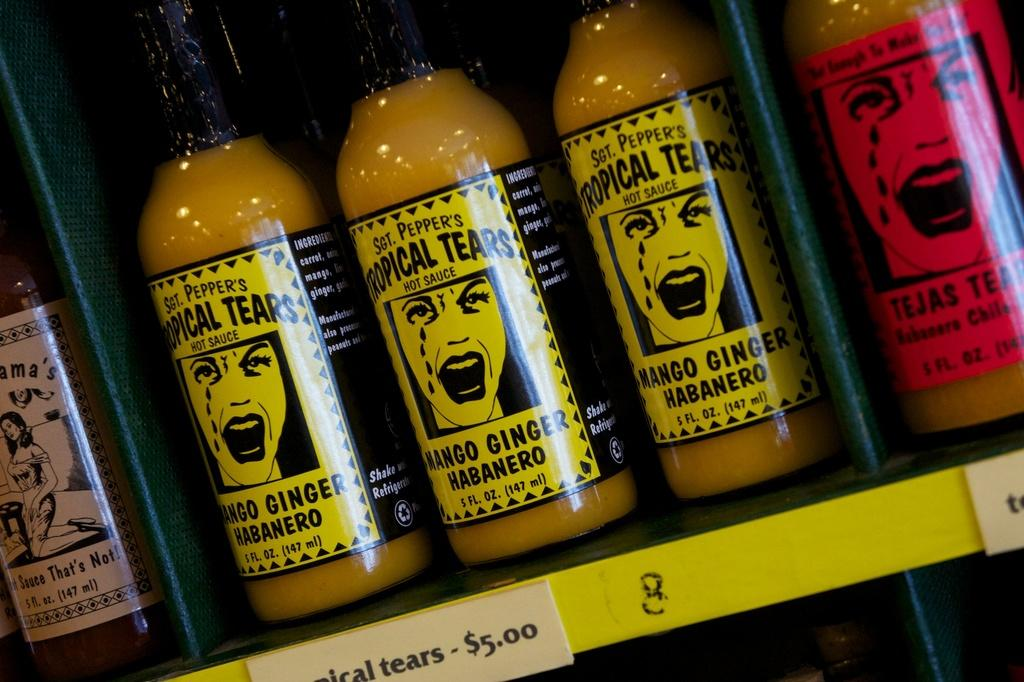<image>
Write a terse but informative summary of the picture. bottles on a shelf with one of them labeled as tropical tears mango ginger habanero 